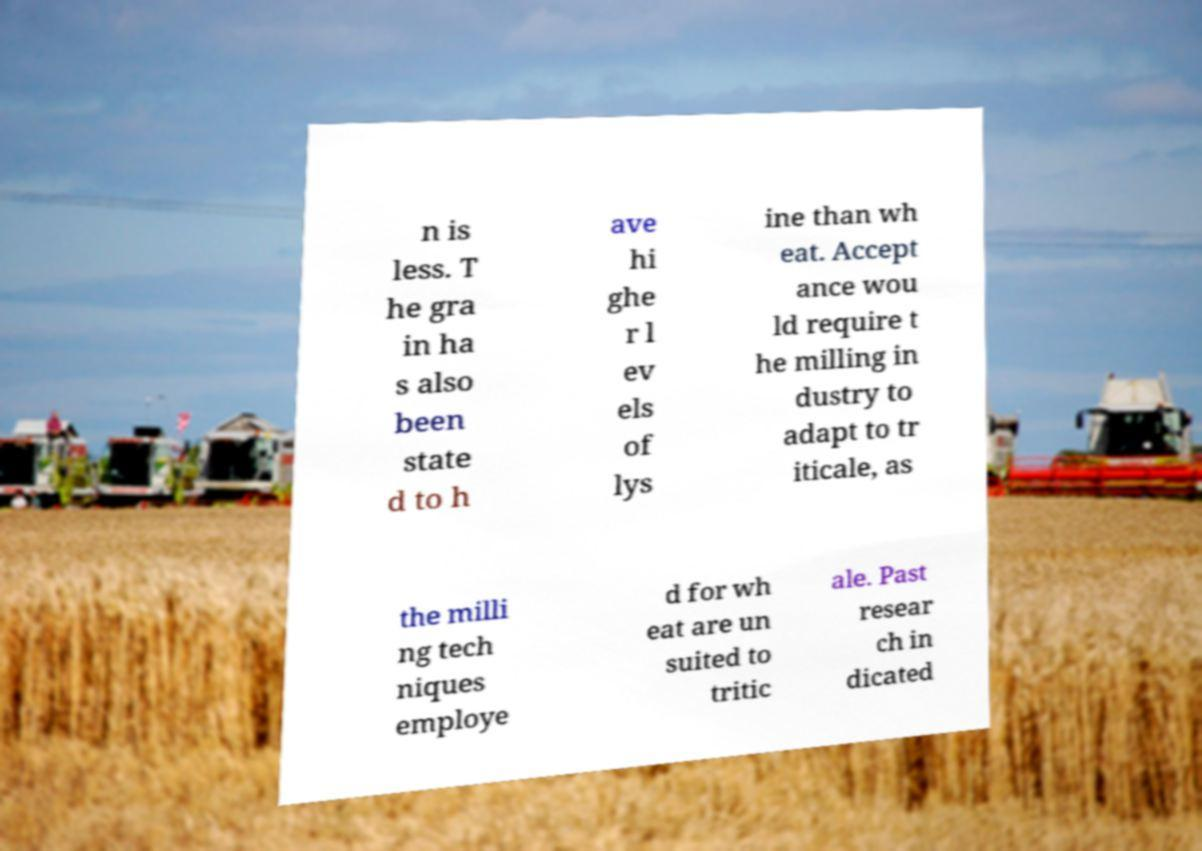There's text embedded in this image that I need extracted. Can you transcribe it verbatim? n is less. T he gra in ha s also been state d to h ave hi ghe r l ev els of lys ine than wh eat. Accept ance wou ld require t he milling in dustry to adapt to tr iticale, as the milli ng tech niques employe d for wh eat are un suited to tritic ale. Past resear ch in dicated 